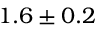Convert formula to latex. <formula><loc_0><loc_0><loc_500><loc_500>1 . 6 \pm 0 . 2</formula> 